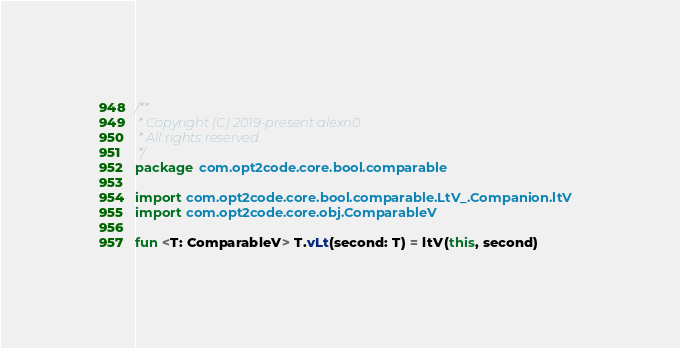Convert code to text. <code><loc_0><loc_0><loc_500><loc_500><_Kotlin_>/**
 * Copyright (C) 2019-present alexn0
 * All rights reserved.
 */
package com.opt2code.core.bool.comparable

import com.opt2code.core.bool.comparable.LtV_.Companion.ltV
import com.opt2code.core.obj.ComparableV

fun <T: ComparableV> T.vLt(second: T) = ltV(this, second)</code> 